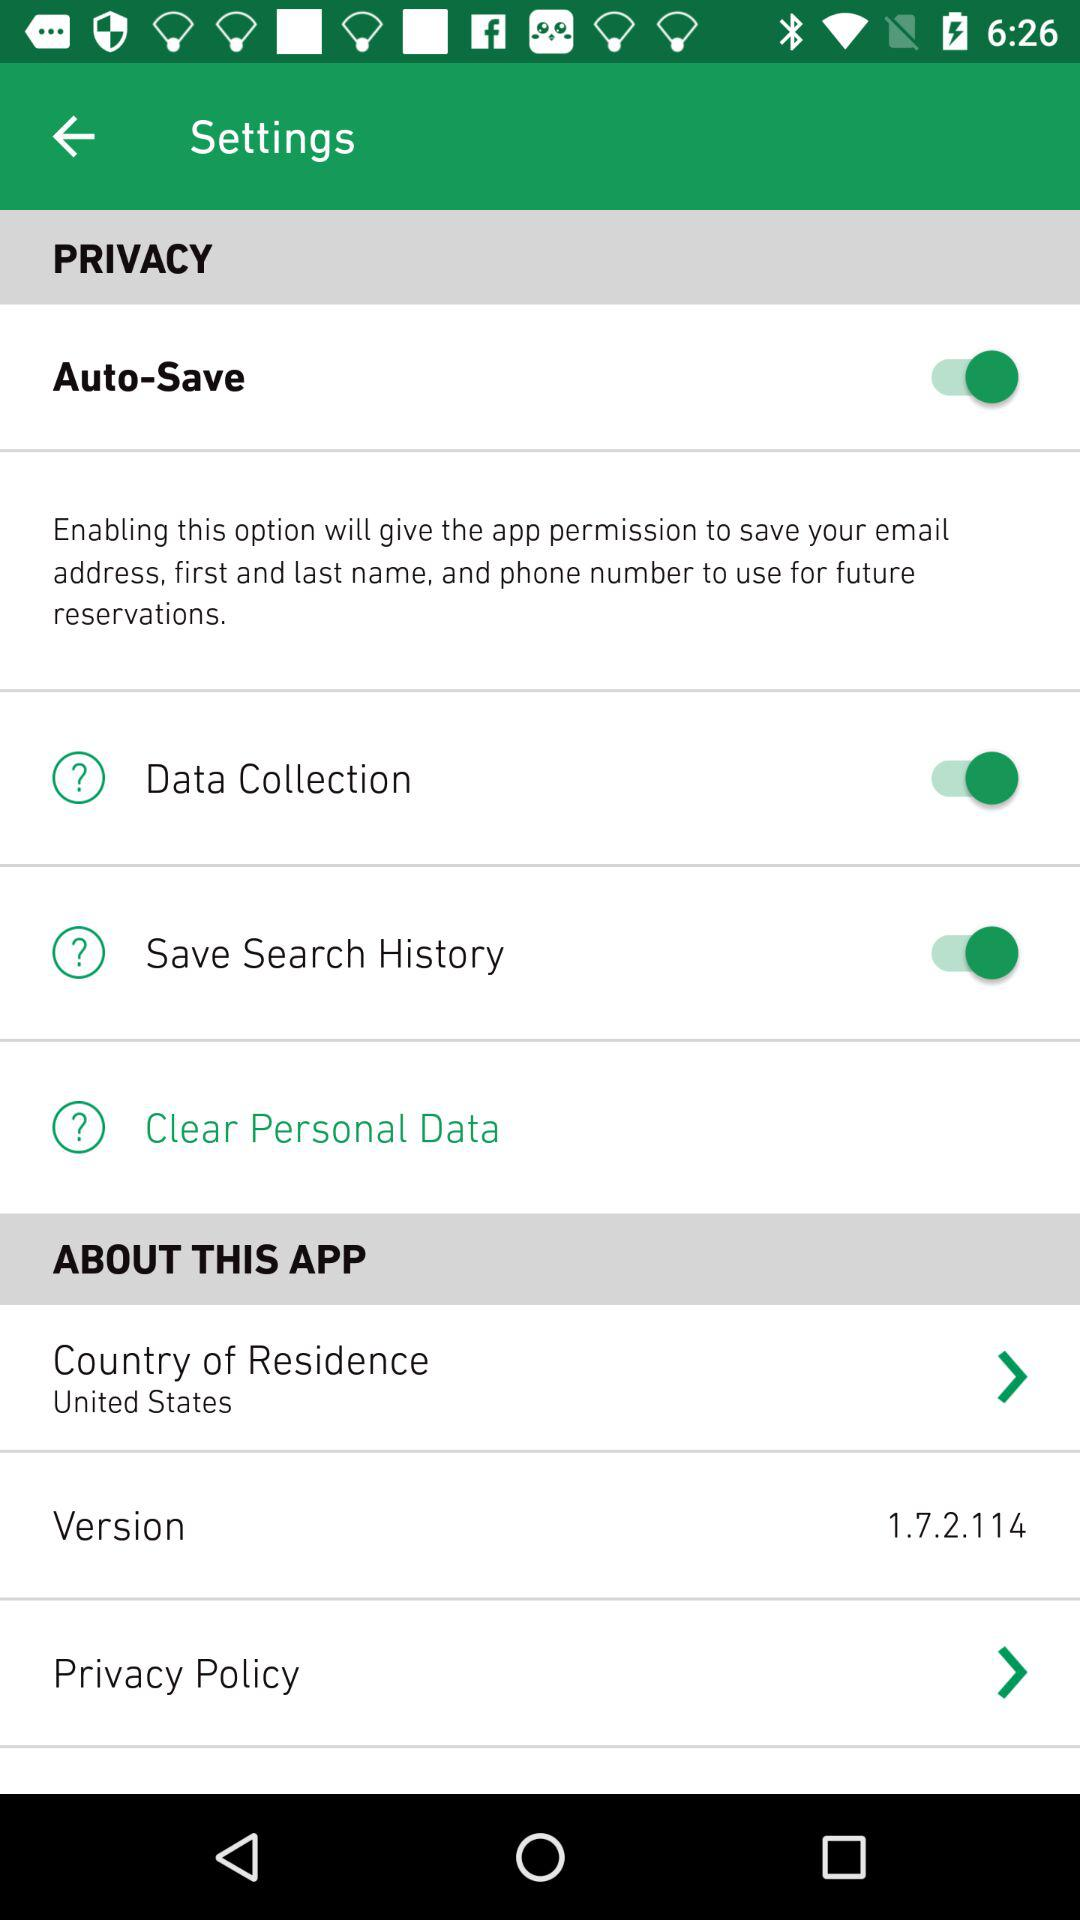By enabling which option will the app get permission? By enabling the option "Auto-Save", the app will get permission. 